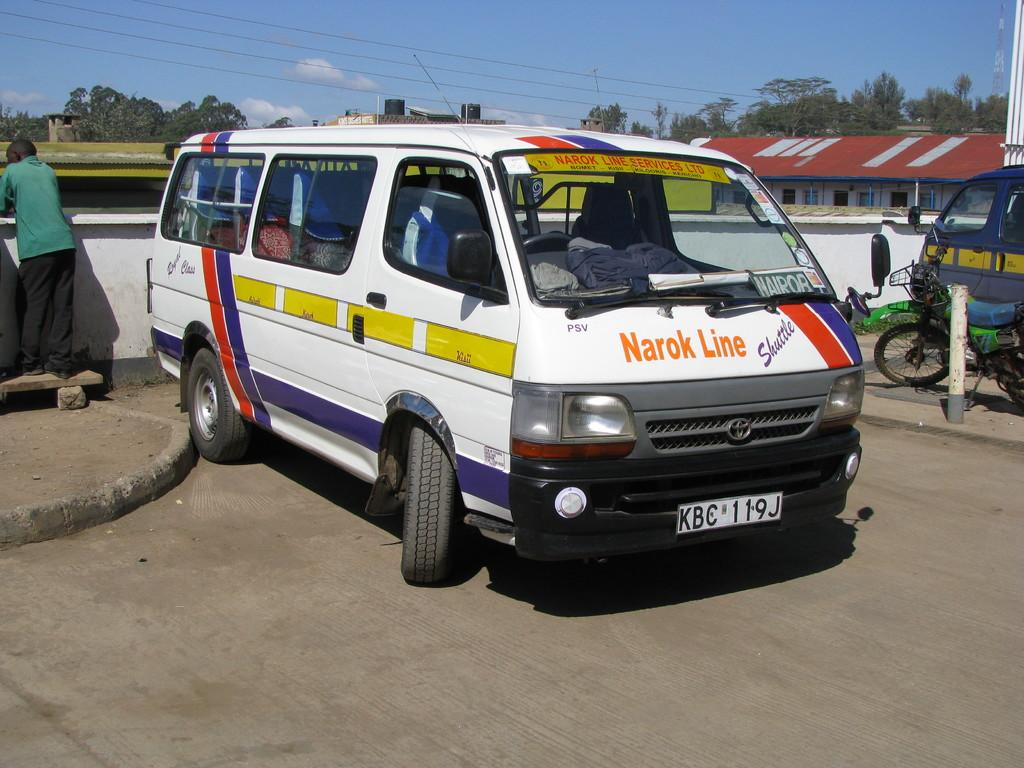Provide a one-sentence caption for the provided image. a parked white window van by narok line. 